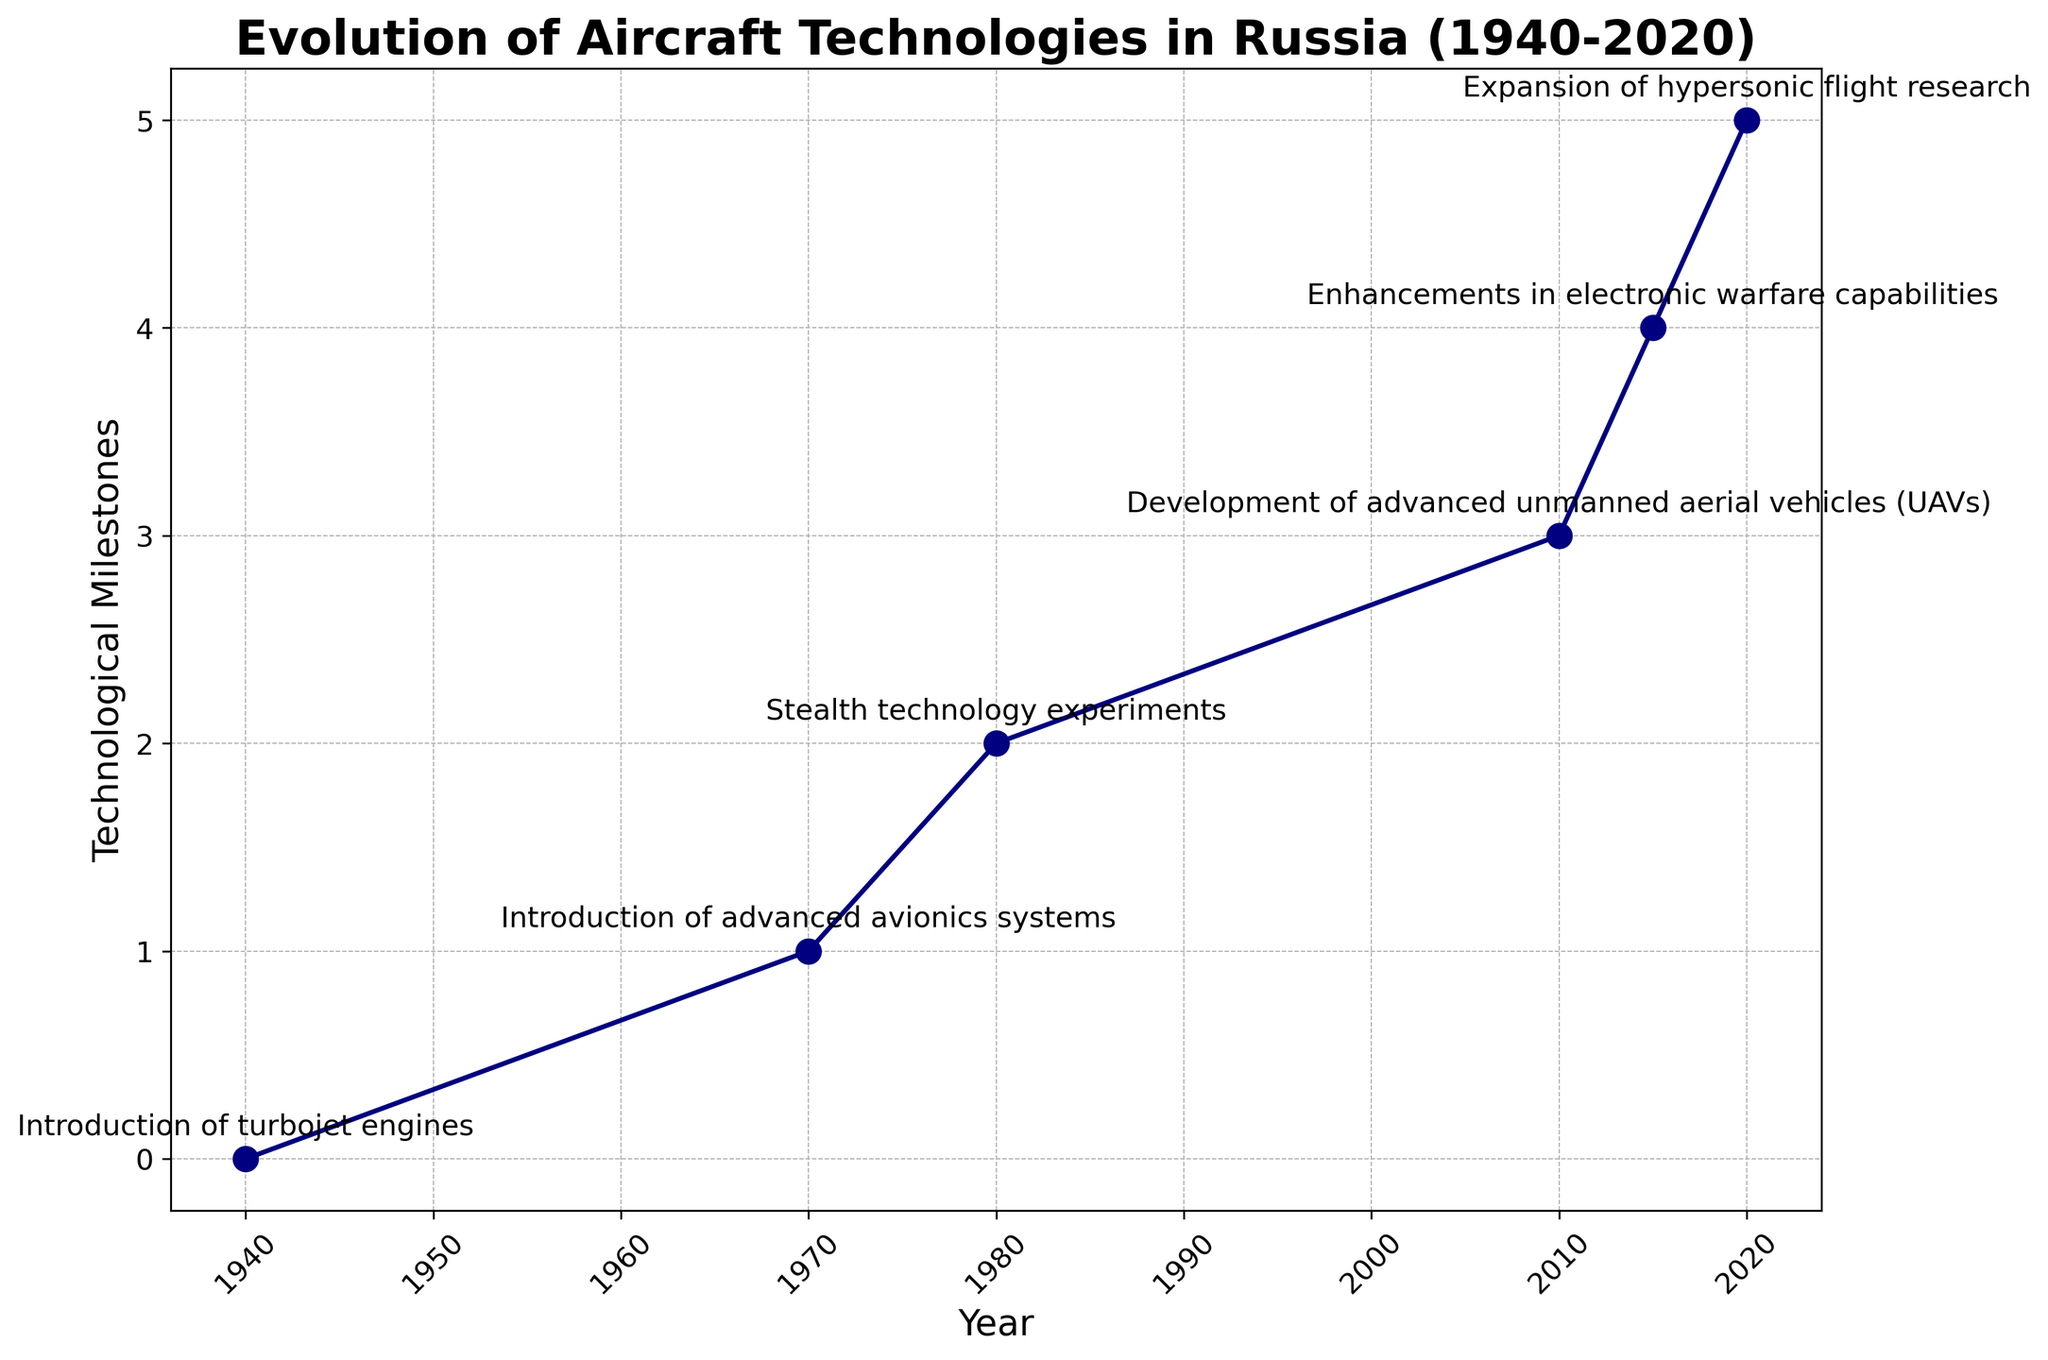When did Russia start developing hypersonic flight technologies? Hypersonic flight research is marked on the plot at the year 2020. Referencing the chart, the expansion of hypersonic flight research began in 2020.
Answer: 2020 Which technological milestone occurred between 1980 and 2010? The plot depicts the evolution of technological advances on a timeline. Reviewing the years between 1980 and 2010, the development of advanced unmanned aerial vehicles (UAVs) in 2010 falls within this range.
Answer: Development of advanced unmanned aerial vehicles (UAVs) Arrange the technological milestones in chronological order. The plot presents each technological advancement alongside its corresponding year. By listing them in order of the years shown, the sequence from 1940 to 2020 is: Introduction of turbojet engines, Introduction of advanced avionics systems, Stealth technology experiments, Development of advanced unmanned aerial vehicles (UAVs), Enhancements in electronic warfare capabilities, Expansion of hypersonic flight research.
Answer: Introduction of turbojet engines, Introduction of advanced avionics systems, Stealth technology experiments, Development of advanced unmanned aerial vehicles (UAVs), Enhancements in electronic warfare capabilities, Expansion of hypersonic flight research How many years passed between the introduction of turbojet engines and the introduction of advanced avionics systems? The figure displays the year for each technological milestone. Advanced avionics systems were introduced in 1970, and turbojet engines in 1940. The difference between these years is calculated as 1970 - 1940.
Answer: 30 years What two technological advances were attained in the 1980-2020 period? The timeline illustrates several technological advancements. Focusing on the interval from 1980 to 2020, the notable advances are Stealth technology experiments (1980), Development of advanced unmanned aerial vehicles (2010), Enhancements in electronic warfare capabilities (2015), and Expansion of hypersonic flight research (2020).
Answer: Stealth technology experiments and Development of advanced unmanned aerial vehicles (UAVs) What is the visual marker used to display each technological milestone? Examining the graphical representation of the figure, each technological milestone is marked by a circle ('o') on the line graph.
Answer: circles Which was the first technology advance shown on the plot? According to the timeline in the figure, the earliest technological advance noted is the 'Introduction of turbojet engines' in 1940.
Answer: Introduction of turbojet engines 